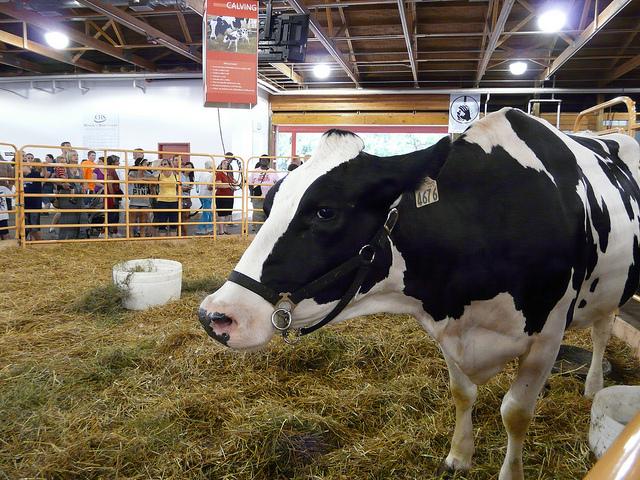Is this cow roaming freely?
Answer briefly. No. Is the girl feeding the cows?
Write a very short answer. No. Is the cow alert?
Keep it brief. Yes. What is keeping the cows in place?
Keep it brief. Fence. Is this cow healthy?
Short answer required. Yes. 